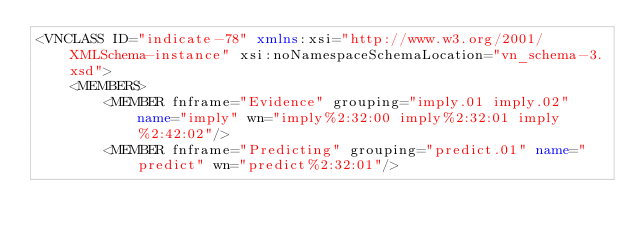<code> <loc_0><loc_0><loc_500><loc_500><_XML_><VNCLASS ID="indicate-78" xmlns:xsi="http://www.w3.org/2001/XMLSchema-instance" xsi:noNamespaceSchemaLocation="vn_schema-3.xsd">
    <MEMBERS>
        <MEMBER fnframe="Evidence" grouping="imply.01 imply.02" name="imply" wn="imply%2:32:00 imply%2:32:01 imply%2:42:02"/>
        <MEMBER fnframe="Predicting" grouping="predict.01" name="predict" wn="predict%2:32:01"/></code> 